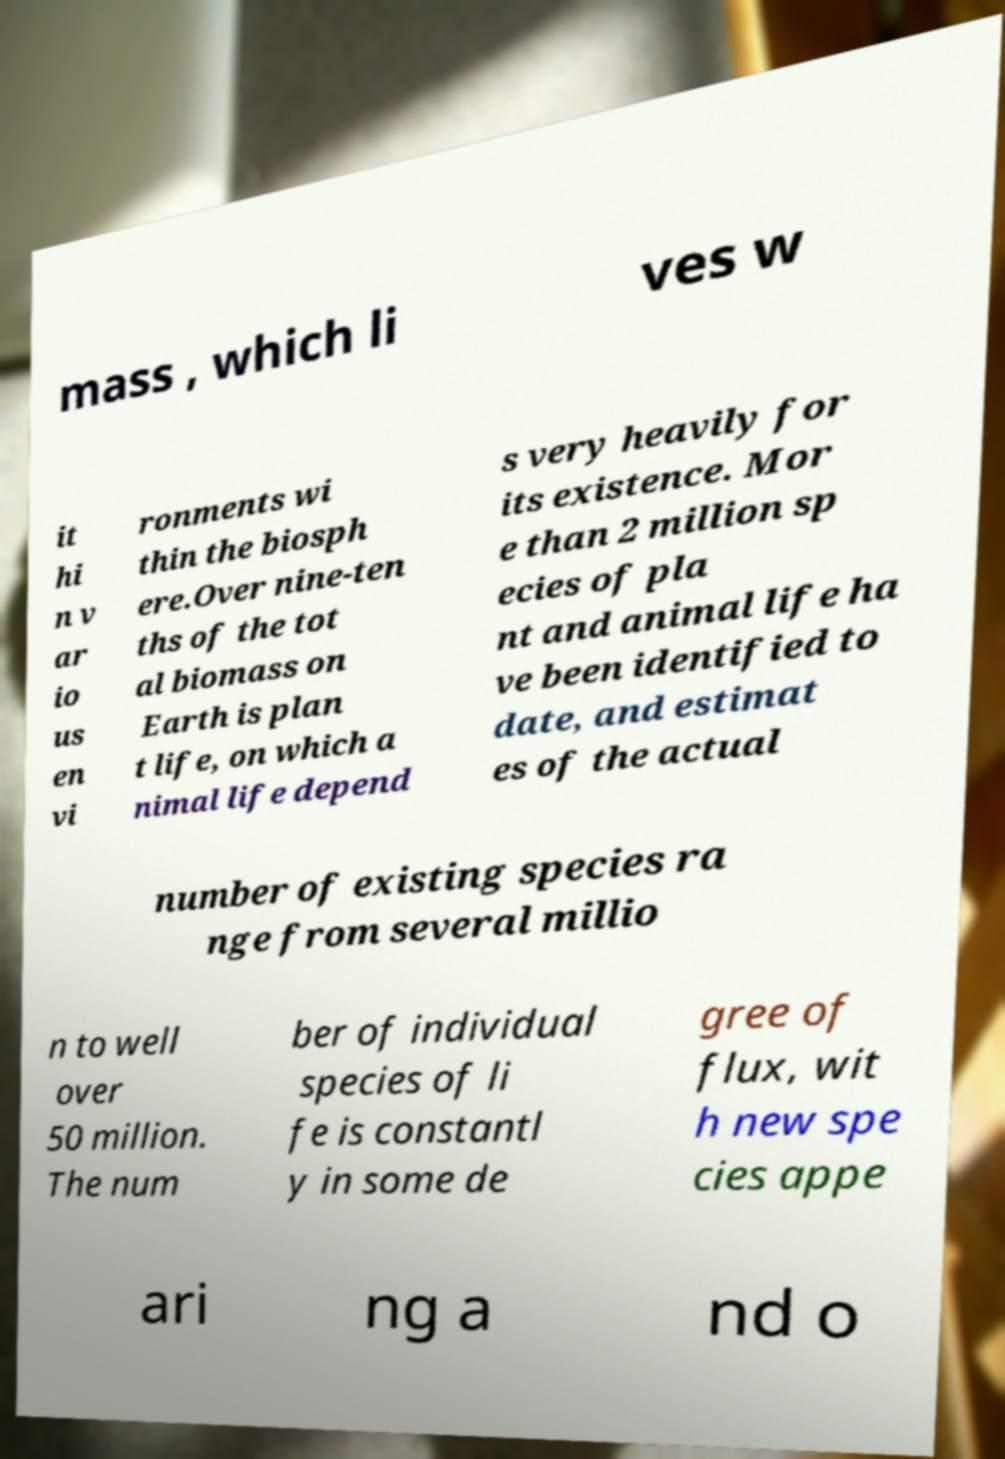Can you accurately transcribe the text from the provided image for me? mass , which li ves w it hi n v ar io us en vi ronments wi thin the biosph ere.Over nine-ten ths of the tot al biomass on Earth is plan t life, on which a nimal life depend s very heavily for its existence. Mor e than 2 million sp ecies of pla nt and animal life ha ve been identified to date, and estimat es of the actual number of existing species ra nge from several millio n to well over 50 million. The num ber of individual species of li fe is constantl y in some de gree of flux, wit h new spe cies appe ari ng a nd o 